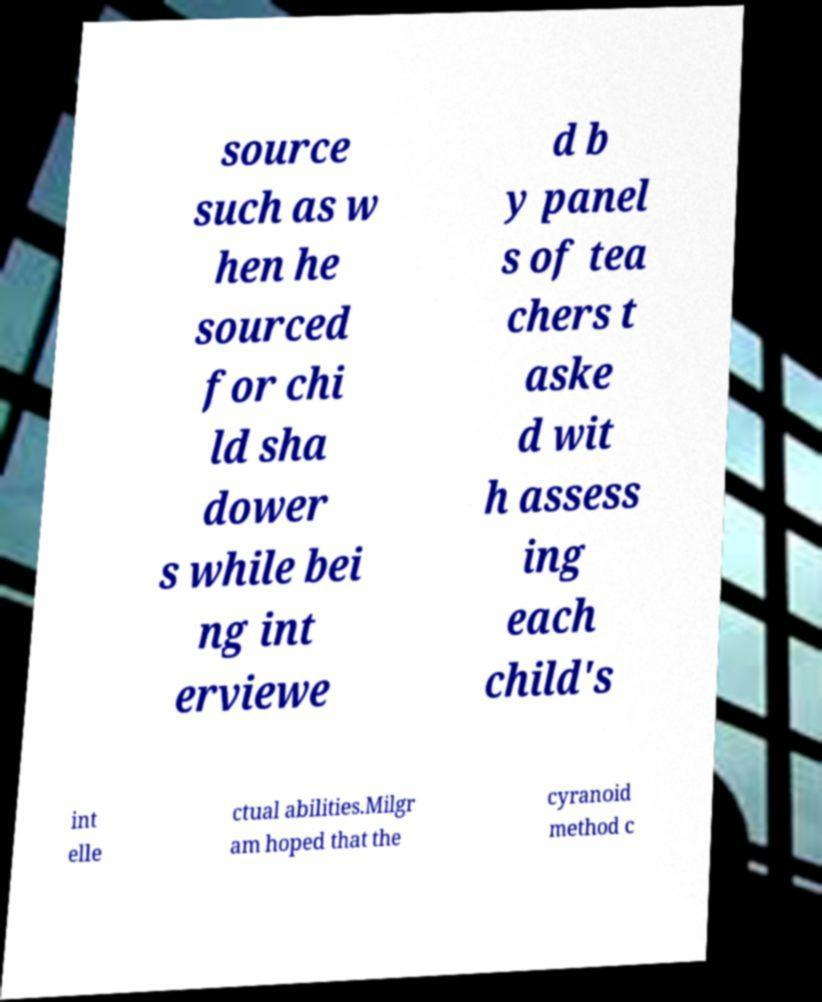Could you assist in decoding the text presented in this image and type it out clearly? source such as w hen he sourced for chi ld sha dower s while bei ng int erviewe d b y panel s of tea chers t aske d wit h assess ing each child's int elle ctual abilities.Milgr am hoped that the cyranoid method c 